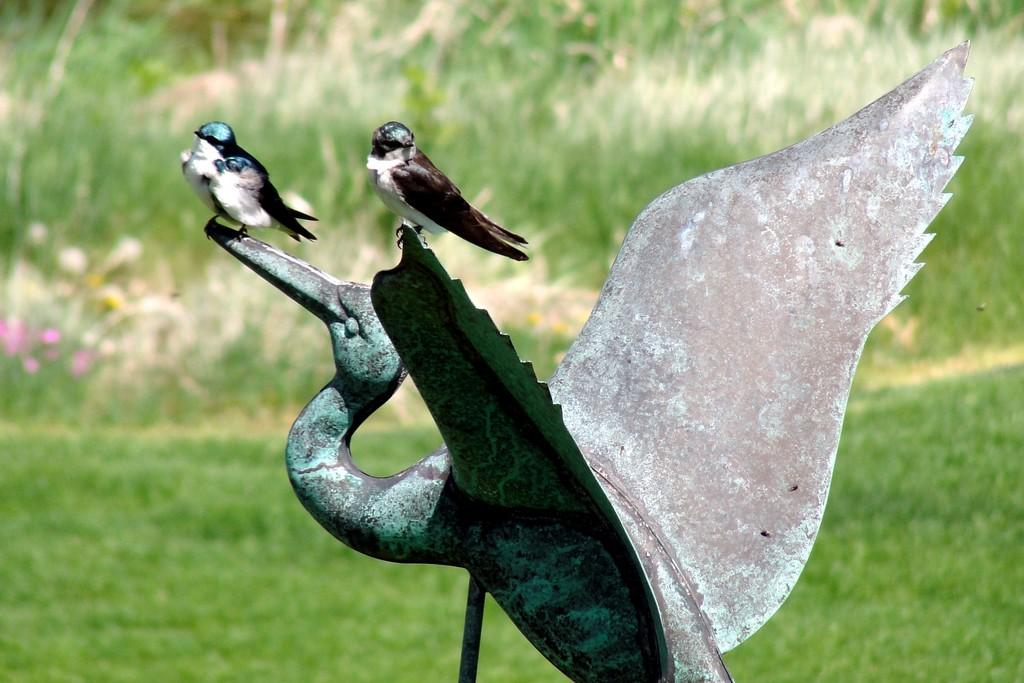How many birds can be seen in the image? There are two birds in the image. What are the birds doing in the image? The birds are sitting on a statue. What type of statue is featured in the image? The statue is of a crane. Where is the statue located in the image? The statue is in the middle of the image. What can be seen in the background of the image? There is grass visible in the background of the image. What type of bell can be heard ringing in the image? There is no bell present in the image, and therefore no sound can be heard. Can you tell me how many bones are visible in the image? There are no bones visible in the image; it features two birds sitting on a statue of a crane. 